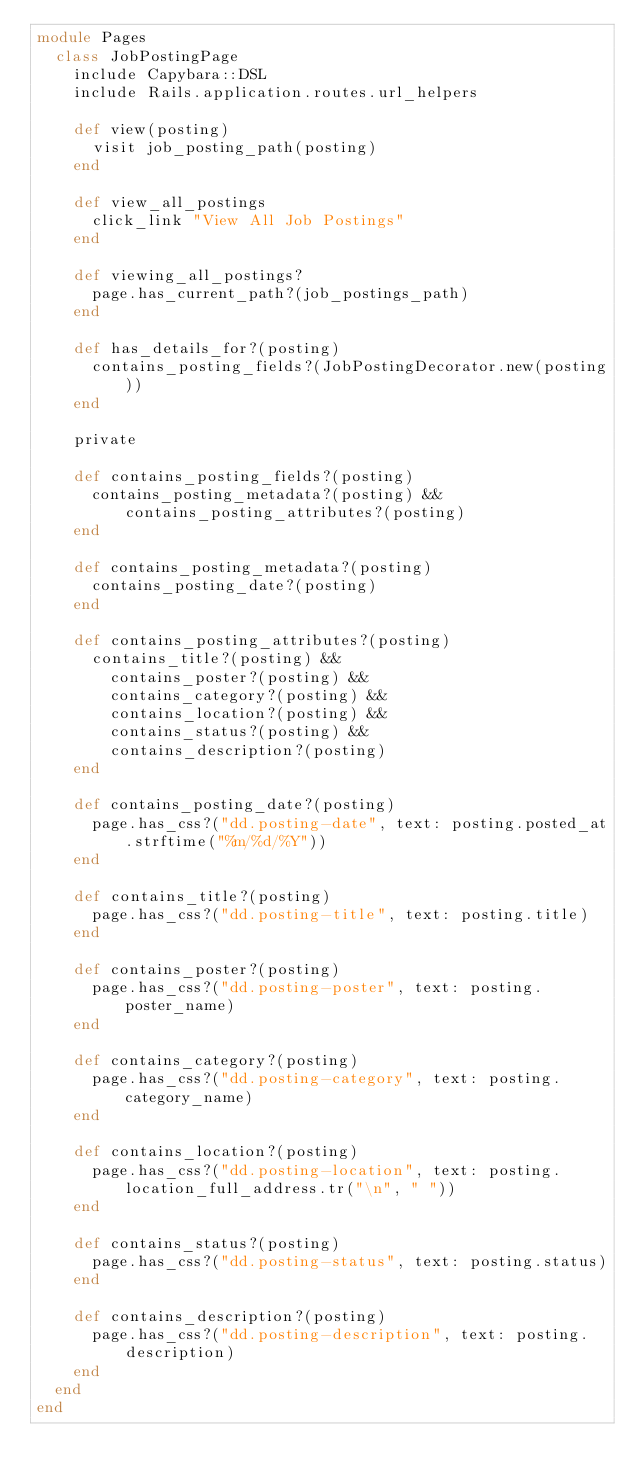<code> <loc_0><loc_0><loc_500><loc_500><_Ruby_>module Pages
  class JobPostingPage
    include Capybara::DSL
    include Rails.application.routes.url_helpers

    def view(posting)
      visit job_posting_path(posting)
    end

    def view_all_postings
      click_link "View All Job Postings"
    end

    def viewing_all_postings?
      page.has_current_path?(job_postings_path)
    end

    def has_details_for?(posting)
      contains_posting_fields?(JobPostingDecorator.new(posting))
    end

    private

    def contains_posting_fields?(posting)
      contains_posting_metadata?(posting) && contains_posting_attributes?(posting)
    end

    def contains_posting_metadata?(posting)
      contains_posting_date?(posting)
    end

    def contains_posting_attributes?(posting)
      contains_title?(posting) &&
        contains_poster?(posting) &&
        contains_category?(posting) &&
        contains_location?(posting) &&
        contains_status?(posting) &&
        contains_description?(posting)
    end

    def contains_posting_date?(posting)
      page.has_css?("dd.posting-date", text: posting.posted_at.strftime("%m/%d/%Y"))
    end

    def contains_title?(posting)
      page.has_css?("dd.posting-title", text: posting.title)
    end

    def contains_poster?(posting)
      page.has_css?("dd.posting-poster", text: posting.poster_name)
    end

    def contains_category?(posting)
      page.has_css?("dd.posting-category", text: posting.category_name)
    end

    def contains_location?(posting)
      page.has_css?("dd.posting-location", text: posting.location_full_address.tr("\n", " "))
    end

    def contains_status?(posting)
      page.has_css?("dd.posting-status", text: posting.status)
    end

    def contains_description?(posting)
      page.has_css?("dd.posting-description", text: posting.description)
    end
  end
end
</code> 